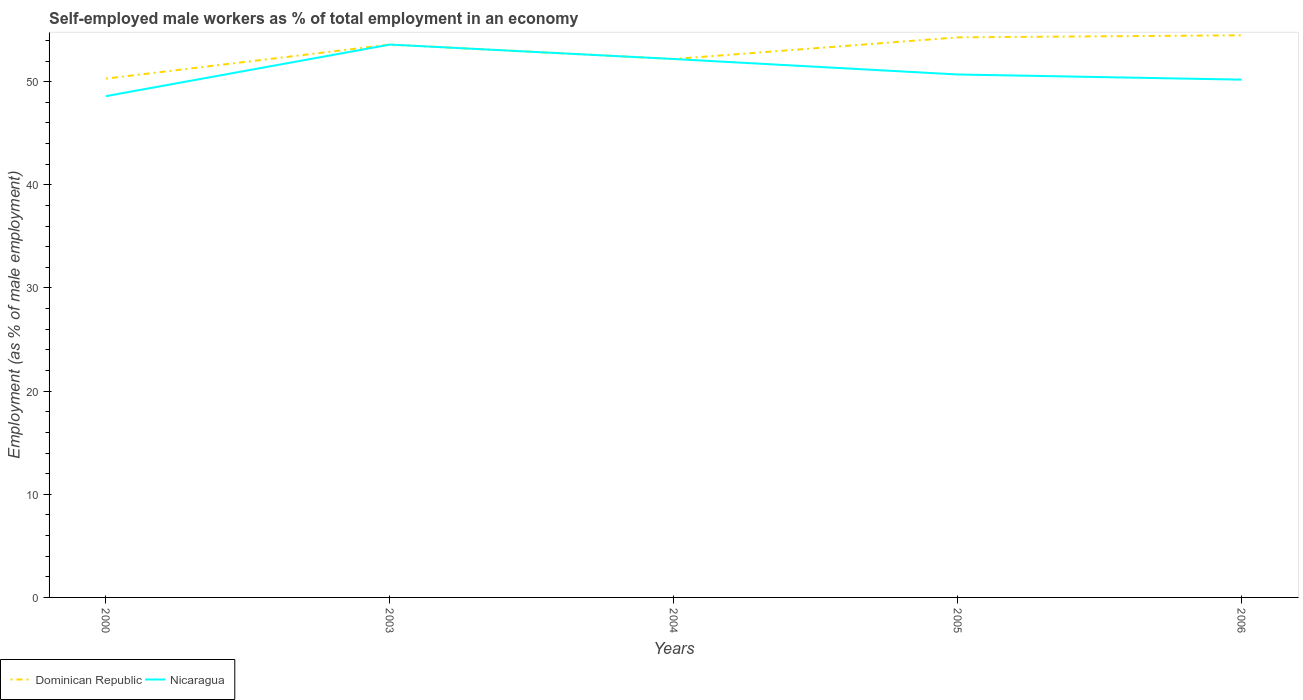Does the line corresponding to Nicaragua intersect with the line corresponding to Dominican Republic?
Keep it short and to the point. Yes. Across all years, what is the maximum percentage of self-employed male workers in Dominican Republic?
Make the answer very short. 50.3. What is the total percentage of self-employed male workers in Nicaragua in the graph?
Make the answer very short. 2.9. What is the difference between the highest and the second highest percentage of self-employed male workers in Nicaragua?
Provide a short and direct response. 5. What is the difference between the highest and the lowest percentage of self-employed male workers in Dominican Republic?
Keep it short and to the point. 3. Is the percentage of self-employed male workers in Nicaragua strictly greater than the percentage of self-employed male workers in Dominican Republic over the years?
Ensure brevity in your answer.  No. What is the difference between two consecutive major ticks on the Y-axis?
Offer a very short reply. 10. Does the graph contain any zero values?
Ensure brevity in your answer.  No. Where does the legend appear in the graph?
Offer a very short reply. Bottom left. How many legend labels are there?
Provide a short and direct response. 2. What is the title of the graph?
Offer a very short reply. Self-employed male workers as % of total employment in an economy. What is the label or title of the Y-axis?
Ensure brevity in your answer.  Employment (as % of male employment). What is the Employment (as % of male employment) in Dominican Republic in 2000?
Your answer should be compact. 50.3. What is the Employment (as % of male employment) in Nicaragua in 2000?
Offer a terse response. 48.6. What is the Employment (as % of male employment) of Dominican Republic in 2003?
Provide a short and direct response. 53.6. What is the Employment (as % of male employment) in Nicaragua in 2003?
Offer a terse response. 53.6. What is the Employment (as % of male employment) of Dominican Republic in 2004?
Give a very brief answer. 52.2. What is the Employment (as % of male employment) in Nicaragua in 2004?
Your answer should be compact. 52.2. What is the Employment (as % of male employment) in Dominican Republic in 2005?
Offer a terse response. 54.3. What is the Employment (as % of male employment) in Nicaragua in 2005?
Ensure brevity in your answer.  50.7. What is the Employment (as % of male employment) of Dominican Republic in 2006?
Your answer should be compact. 54.5. What is the Employment (as % of male employment) of Nicaragua in 2006?
Provide a short and direct response. 50.2. Across all years, what is the maximum Employment (as % of male employment) in Dominican Republic?
Your answer should be compact. 54.5. Across all years, what is the maximum Employment (as % of male employment) of Nicaragua?
Offer a terse response. 53.6. Across all years, what is the minimum Employment (as % of male employment) of Dominican Republic?
Make the answer very short. 50.3. Across all years, what is the minimum Employment (as % of male employment) of Nicaragua?
Give a very brief answer. 48.6. What is the total Employment (as % of male employment) in Dominican Republic in the graph?
Provide a succinct answer. 264.9. What is the total Employment (as % of male employment) of Nicaragua in the graph?
Offer a terse response. 255.3. What is the difference between the Employment (as % of male employment) of Dominican Republic in 2000 and that in 2003?
Give a very brief answer. -3.3. What is the difference between the Employment (as % of male employment) of Dominican Republic in 2000 and that in 2004?
Give a very brief answer. -1.9. What is the difference between the Employment (as % of male employment) of Nicaragua in 2000 and that in 2005?
Keep it short and to the point. -2.1. What is the difference between the Employment (as % of male employment) of Nicaragua in 2003 and that in 2004?
Offer a very short reply. 1.4. What is the difference between the Employment (as % of male employment) of Dominican Republic in 2003 and that in 2005?
Your response must be concise. -0.7. What is the difference between the Employment (as % of male employment) of Dominican Republic in 2003 and that in 2006?
Keep it short and to the point. -0.9. What is the difference between the Employment (as % of male employment) of Dominican Republic in 2004 and that in 2005?
Offer a very short reply. -2.1. What is the difference between the Employment (as % of male employment) of Nicaragua in 2004 and that in 2005?
Your answer should be very brief. 1.5. What is the difference between the Employment (as % of male employment) of Nicaragua in 2004 and that in 2006?
Your response must be concise. 2. What is the difference between the Employment (as % of male employment) in Dominican Republic in 2005 and that in 2006?
Your answer should be compact. -0.2. What is the difference between the Employment (as % of male employment) of Dominican Republic in 2000 and the Employment (as % of male employment) of Nicaragua in 2004?
Keep it short and to the point. -1.9. What is the difference between the Employment (as % of male employment) of Dominican Republic in 2000 and the Employment (as % of male employment) of Nicaragua in 2005?
Your response must be concise. -0.4. What is the difference between the Employment (as % of male employment) of Dominican Republic in 2000 and the Employment (as % of male employment) of Nicaragua in 2006?
Your answer should be very brief. 0.1. What is the difference between the Employment (as % of male employment) of Dominican Republic in 2003 and the Employment (as % of male employment) of Nicaragua in 2005?
Keep it short and to the point. 2.9. What is the difference between the Employment (as % of male employment) in Dominican Republic in 2003 and the Employment (as % of male employment) in Nicaragua in 2006?
Keep it short and to the point. 3.4. What is the difference between the Employment (as % of male employment) in Dominican Republic in 2004 and the Employment (as % of male employment) in Nicaragua in 2006?
Keep it short and to the point. 2. What is the difference between the Employment (as % of male employment) in Dominican Republic in 2005 and the Employment (as % of male employment) in Nicaragua in 2006?
Make the answer very short. 4.1. What is the average Employment (as % of male employment) of Dominican Republic per year?
Ensure brevity in your answer.  52.98. What is the average Employment (as % of male employment) of Nicaragua per year?
Your response must be concise. 51.06. In the year 2000, what is the difference between the Employment (as % of male employment) of Dominican Republic and Employment (as % of male employment) of Nicaragua?
Offer a very short reply. 1.7. In the year 2003, what is the difference between the Employment (as % of male employment) of Dominican Republic and Employment (as % of male employment) of Nicaragua?
Provide a succinct answer. 0. In the year 2004, what is the difference between the Employment (as % of male employment) in Dominican Republic and Employment (as % of male employment) in Nicaragua?
Give a very brief answer. 0. What is the ratio of the Employment (as % of male employment) in Dominican Republic in 2000 to that in 2003?
Keep it short and to the point. 0.94. What is the ratio of the Employment (as % of male employment) in Nicaragua in 2000 to that in 2003?
Give a very brief answer. 0.91. What is the ratio of the Employment (as % of male employment) in Dominican Republic in 2000 to that in 2004?
Make the answer very short. 0.96. What is the ratio of the Employment (as % of male employment) in Nicaragua in 2000 to that in 2004?
Give a very brief answer. 0.93. What is the ratio of the Employment (as % of male employment) of Dominican Republic in 2000 to that in 2005?
Offer a terse response. 0.93. What is the ratio of the Employment (as % of male employment) in Nicaragua in 2000 to that in 2005?
Your answer should be compact. 0.96. What is the ratio of the Employment (as % of male employment) of Dominican Republic in 2000 to that in 2006?
Offer a terse response. 0.92. What is the ratio of the Employment (as % of male employment) of Nicaragua in 2000 to that in 2006?
Ensure brevity in your answer.  0.97. What is the ratio of the Employment (as % of male employment) in Dominican Republic in 2003 to that in 2004?
Provide a short and direct response. 1.03. What is the ratio of the Employment (as % of male employment) of Nicaragua in 2003 to that in 2004?
Your answer should be very brief. 1.03. What is the ratio of the Employment (as % of male employment) in Dominican Republic in 2003 to that in 2005?
Offer a terse response. 0.99. What is the ratio of the Employment (as % of male employment) of Nicaragua in 2003 to that in 2005?
Your answer should be very brief. 1.06. What is the ratio of the Employment (as % of male employment) in Dominican Republic in 2003 to that in 2006?
Make the answer very short. 0.98. What is the ratio of the Employment (as % of male employment) of Nicaragua in 2003 to that in 2006?
Ensure brevity in your answer.  1.07. What is the ratio of the Employment (as % of male employment) of Dominican Republic in 2004 to that in 2005?
Offer a terse response. 0.96. What is the ratio of the Employment (as % of male employment) of Nicaragua in 2004 to that in 2005?
Ensure brevity in your answer.  1.03. What is the ratio of the Employment (as % of male employment) of Dominican Republic in 2004 to that in 2006?
Provide a succinct answer. 0.96. What is the ratio of the Employment (as % of male employment) in Nicaragua in 2004 to that in 2006?
Your answer should be very brief. 1.04. What is the ratio of the Employment (as % of male employment) in Nicaragua in 2005 to that in 2006?
Your answer should be compact. 1.01. 